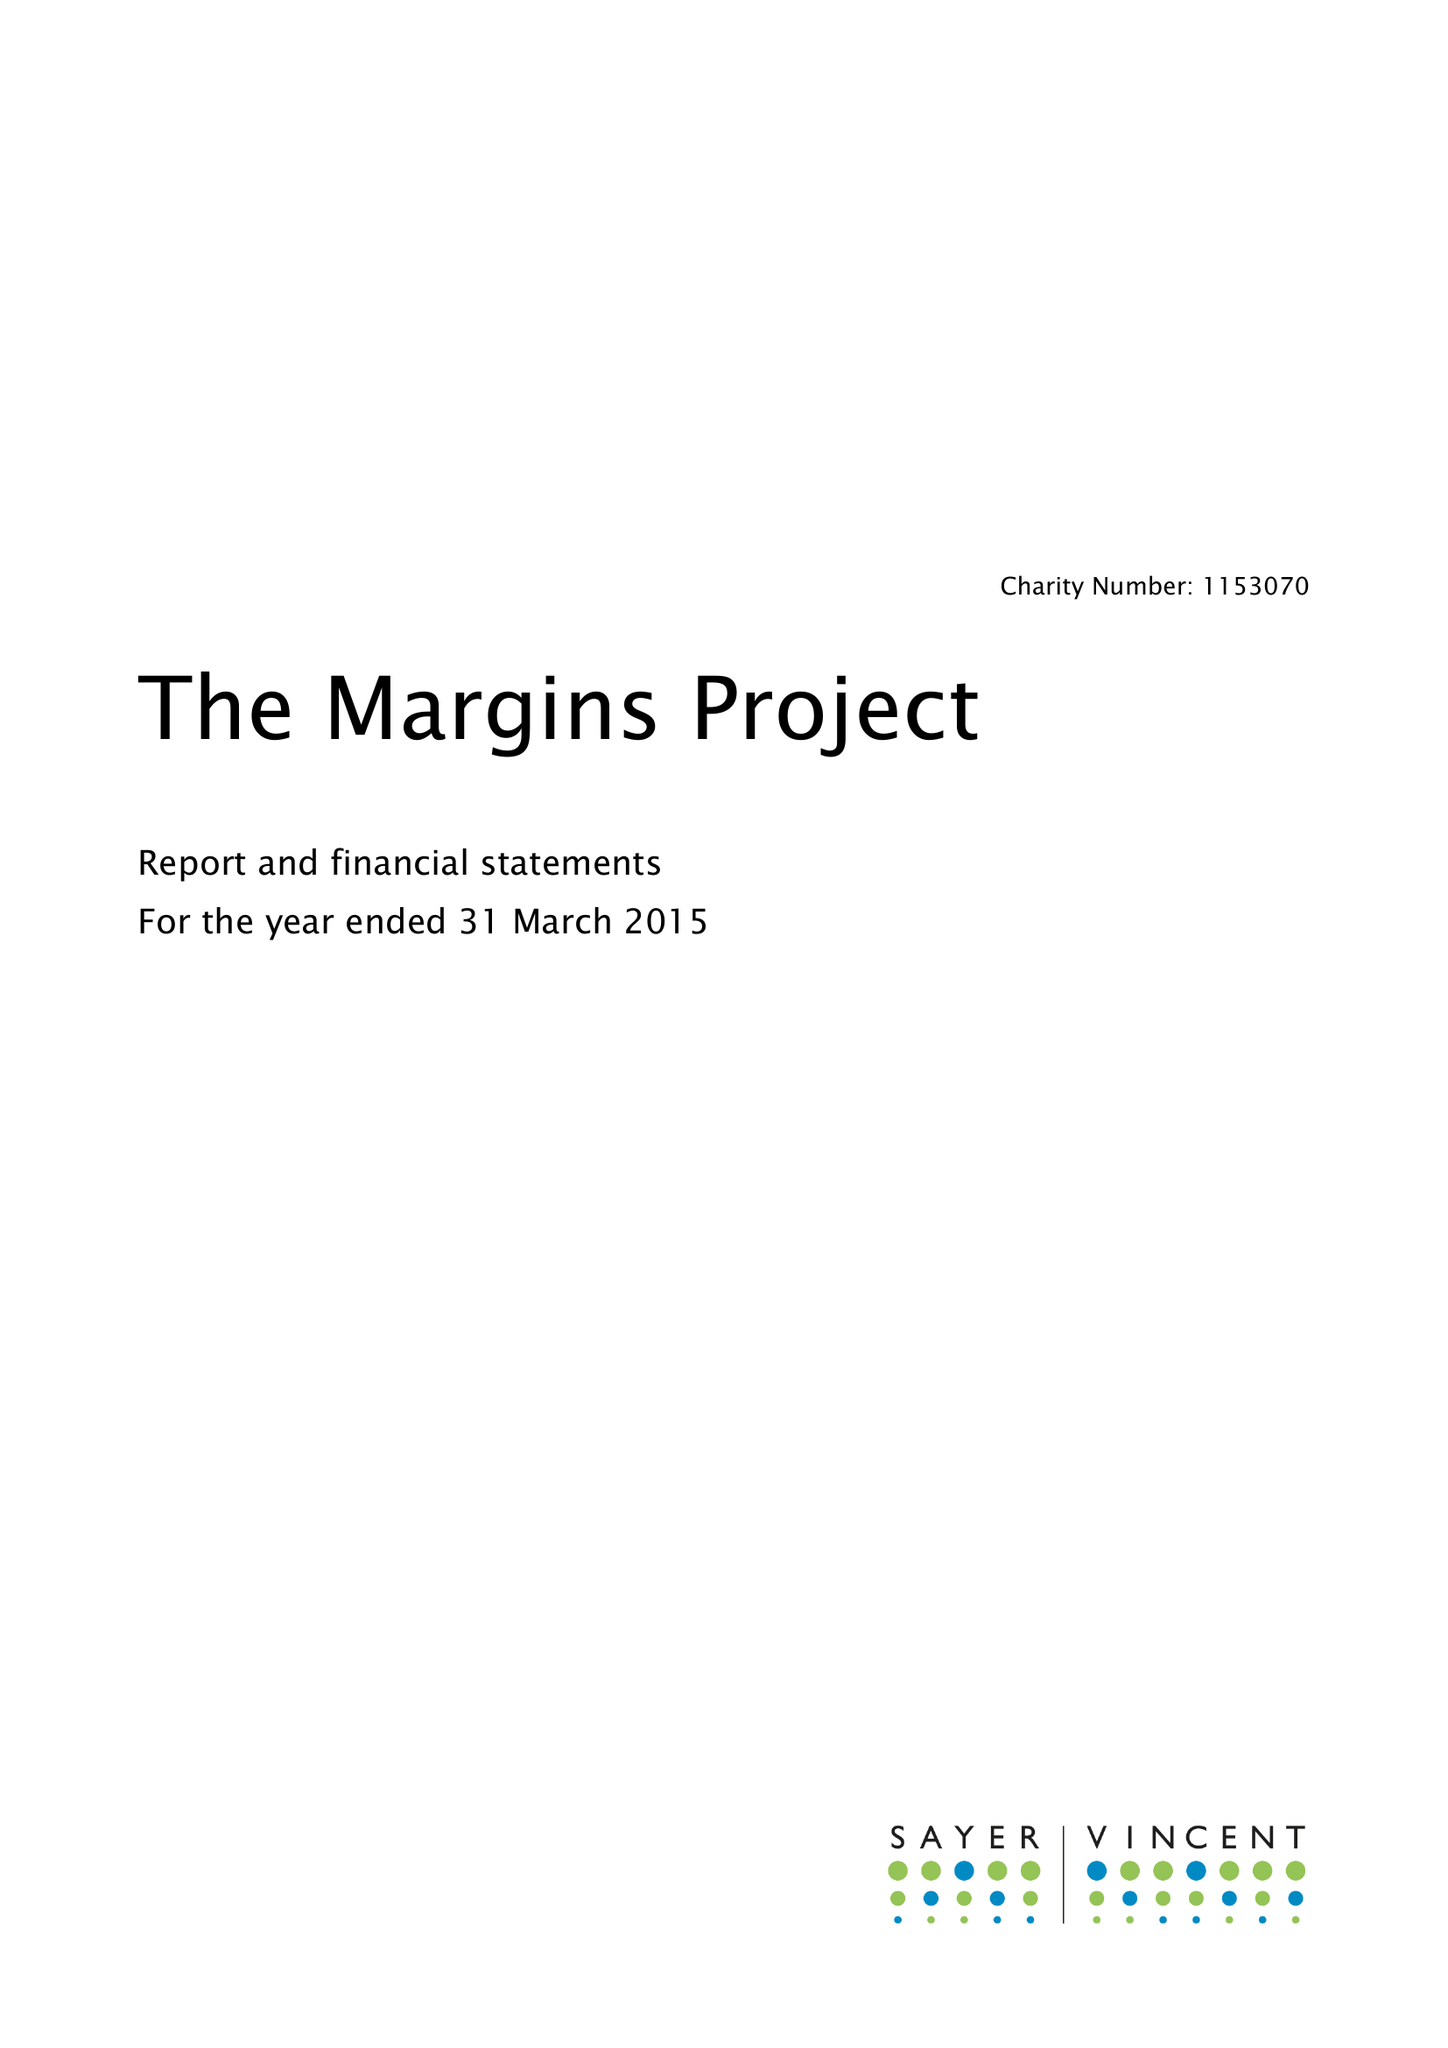What is the value for the charity_name?
Answer the question using a single word or phrase. The Margins Project 